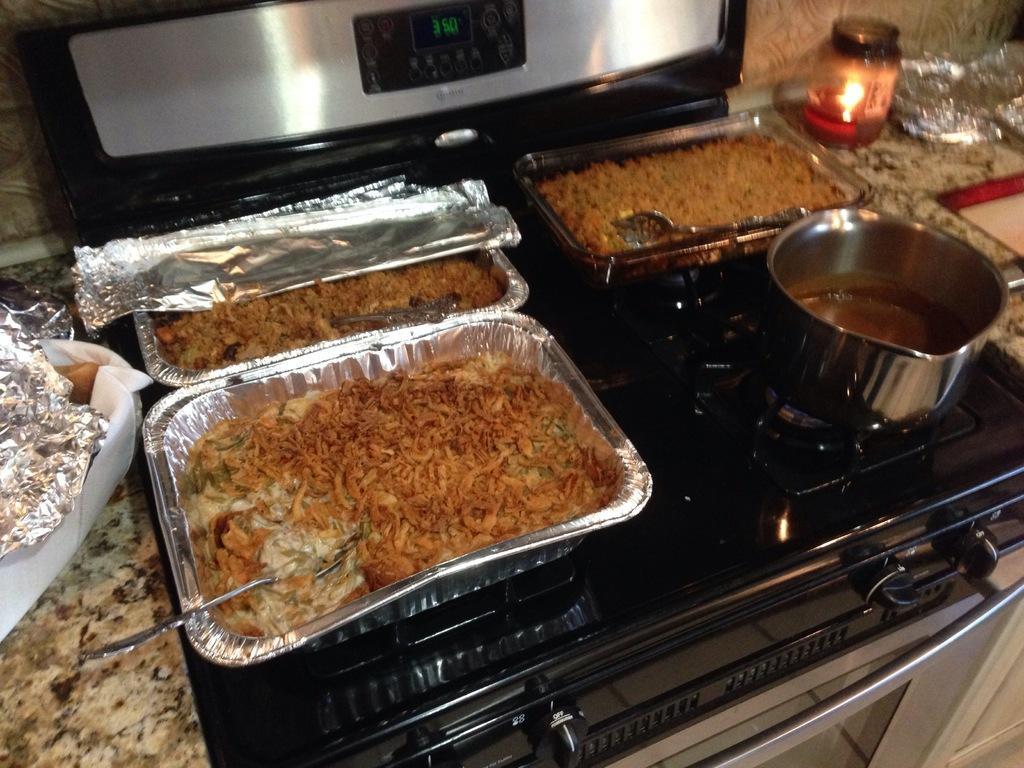Can you describe this image briefly? In this picture there are food items, candle, spoons, bowl and aluminium sheets. At the top there is a microwave oven. 